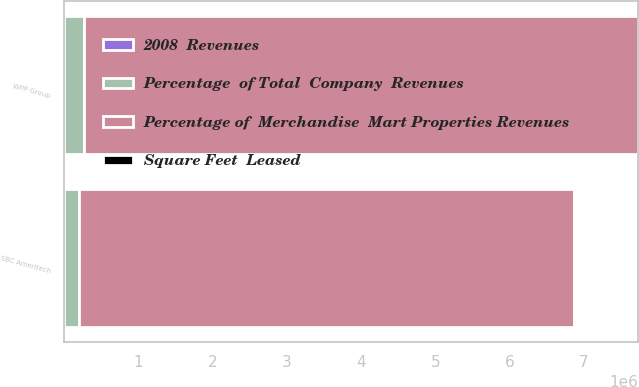<chart> <loc_0><loc_0><loc_500><loc_500><stacked_bar_chart><ecel><fcel>WPP Group<fcel>SBC Ameritech<nl><fcel>Percentage  of Total  Company  Revenues<fcel>270000<fcel>193000<nl><fcel>Percentage of  Merchandise  Mart Properties Revenues<fcel>7.463e+06<fcel>6.679e+06<nl><fcel>Square Feet  Leased<fcel>2.7<fcel>2.4<nl><fcel>2008  Revenues<fcel>0.3<fcel>0.2<nl></chart> 